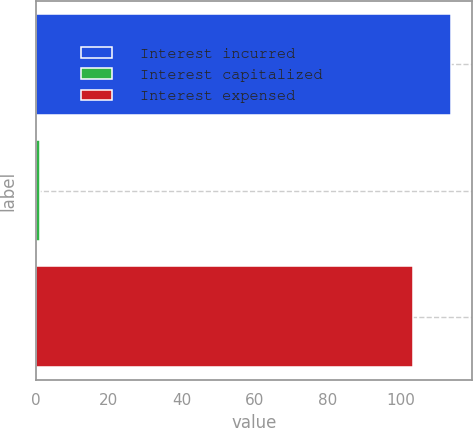<chart> <loc_0><loc_0><loc_500><loc_500><bar_chart><fcel>Interest incurred<fcel>Interest capitalized<fcel>Interest expensed<nl><fcel>113.63<fcel>1.1<fcel>103.3<nl></chart> 